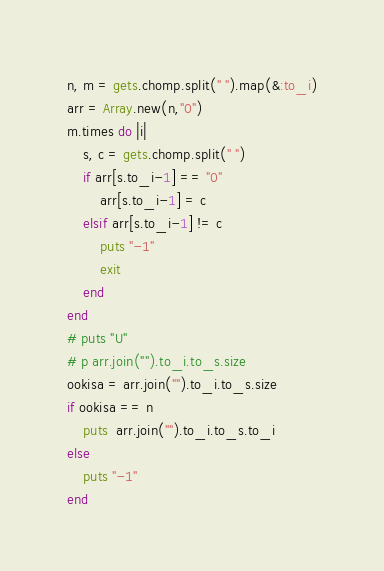<code> <loc_0><loc_0><loc_500><loc_500><_Ruby_>n, m = gets.chomp.split(" ").map(&:to_i)
arr = Array.new(n,"0")
m.times do |i|
    s, c = gets.chomp.split(" ")
    if arr[s.to_i-1] == "0"
        arr[s.to_i-1] = c
    elsif arr[s.to_i-1] != c
        puts "-1"
        exit
    end
end
# puts "U"
# p arr.join("").to_i.to_s.size
ookisa = arr.join("").to_i.to_s.size
if ookisa == n
    puts  arr.join("").to_i.to_s.to_i
else
    puts "-1"
end
</code> 